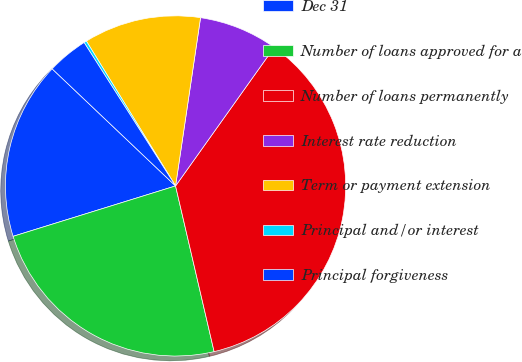Convert chart to OTSL. <chart><loc_0><loc_0><loc_500><loc_500><pie_chart><fcel>Dec 31<fcel>Number of loans approved for a<fcel>Number of loans permanently<fcel>Interest rate reduction<fcel>Term or payment extension<fcel>Principal and/or interest<fcel>Principal forgiveness<nl><fcel>16.87%<fcel>23.85%<fcel>36.51%<fcel>7.5%<fcel>11.13%<fcel>0.25%<fcel>3.88%<nl></chart> 